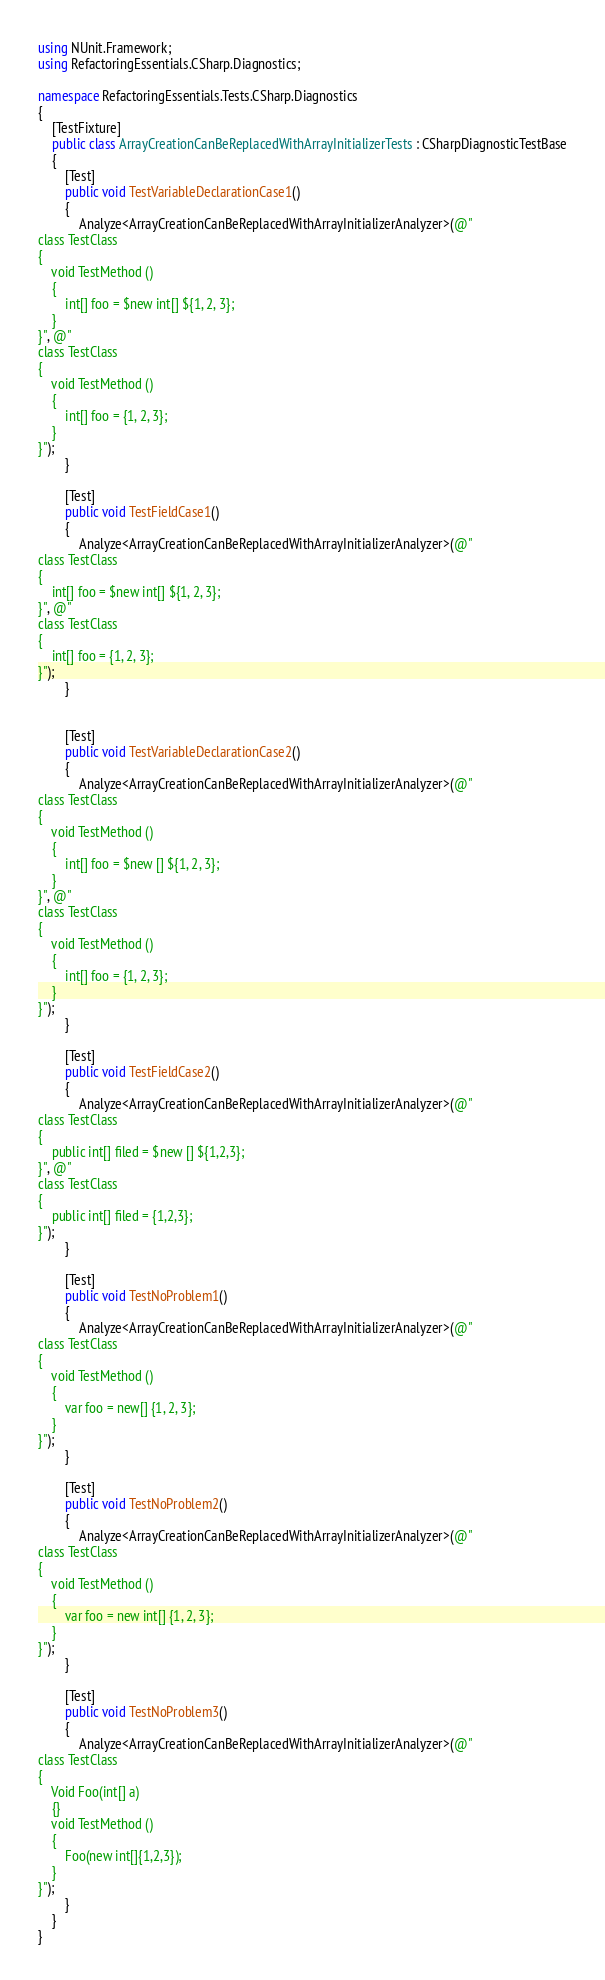Convert code to text. <code><loc_0><loc_0><loc_500><loc_500><_C#_>using NUnit.Framework;
using RefactoringEssentials.CSharp.Diagnostics;

namespace RefactoringEssentials.Tests.CSharp.Diagnostics
{
    [TestFixture]
    public class ArrayCreationCanBeReplacedWithArrayInitializerTests : CSharpDiagnosticTestBase
    {
        [Test]
        public void TestVariableDeclarationCase1()
        {
            Analyze<ArrayCreationCanBeReplacedWithArrayInitializerAnalyzer>(@"
class TestClass
{
	void TestMethod ()
	{
		int[] foo = $new int[] ${1, 2, 3};
	}
}", @"
class TestClass
{
	void TestMethod ()
	{
		int[] foo = {1, 2, 3};
	}
}");
        }

        [Test]
        public void TestFieldCase1()
        {
            Analyze<ArrayCreationCanBeReplacedWithArrayInitializerAnalyzer>(@"
class TestClass
{
	int[] foo = $new int[] ${1, 2, 3};
}", @"
class TestClass
{
	int[] foo = {1, 2, 3};
}");
        }


        [Test]
        public void TestVariableDeclarationCase2()
        {
            Analyze<ArrayCreationCanBeReplacedWithArrayInitializerAnalyzer>(@"
class TestClass
{
	void TestMethod ()
	{
		int[] foo = $new [] ${1, 2, 3};
	}
}", @"
class TestClass
{
	void TestMethod ()
	{
		int[] foo = {1, 2, 3};
	}
}");
        }

        [Test]
        public void TestFieldCase2()
        {
            Analyze<ArrayCreationCanBeReplacedWithArrayInitializerAnalyzer>(@"
class TestClass
{
	public int[] filed = $new [] ${1,2,3};
}", @"
class TestClass
{
	public int[] filed = {1,2,3};
}");
        }

        [Test]
        public void TestNoProblem1()
        {
            Analyze<ArrayCreationCanBeReplacedWithArrayInitializerAnalyzer>(@"
class TestClass
{
	void TestMethod ()
	{
		var foo = new[] {1, 2, 3};
	}
}");
        }

        [Test]
        public void TestNoProblem2()
        {
            Analyze<ArrayCreationCanBeReplacedWithArrayInitializerAnalyzer>(@"
class TestClass
{
	void TestMethod ()
	{
		var foo = new int[] {1, 2, 3};
	}
}");
        }

        [Test]
        public void TestNoProblem3()
        {
            Analyze<ArrayCreationCanBeReplacedWithArrayInitializerAnalyzer>(@"
class TestClass
{
	Void Foo(int[] a)
	{}
	void TestMethod ()
	{
		Foo(new int[]{1,2,3});
	}
}");
        }
    }
}
</code> 